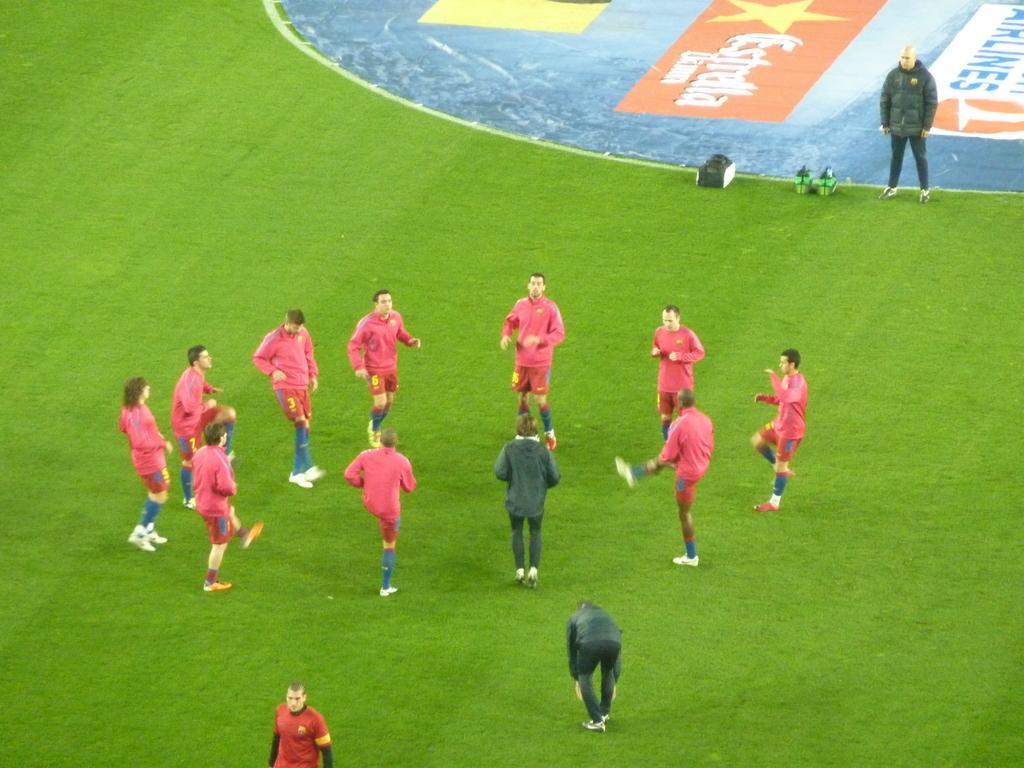Describe this image in one or two sentences. These people are doing warm up and this person standing. We can see objects on green surface and we can see hoarding. 